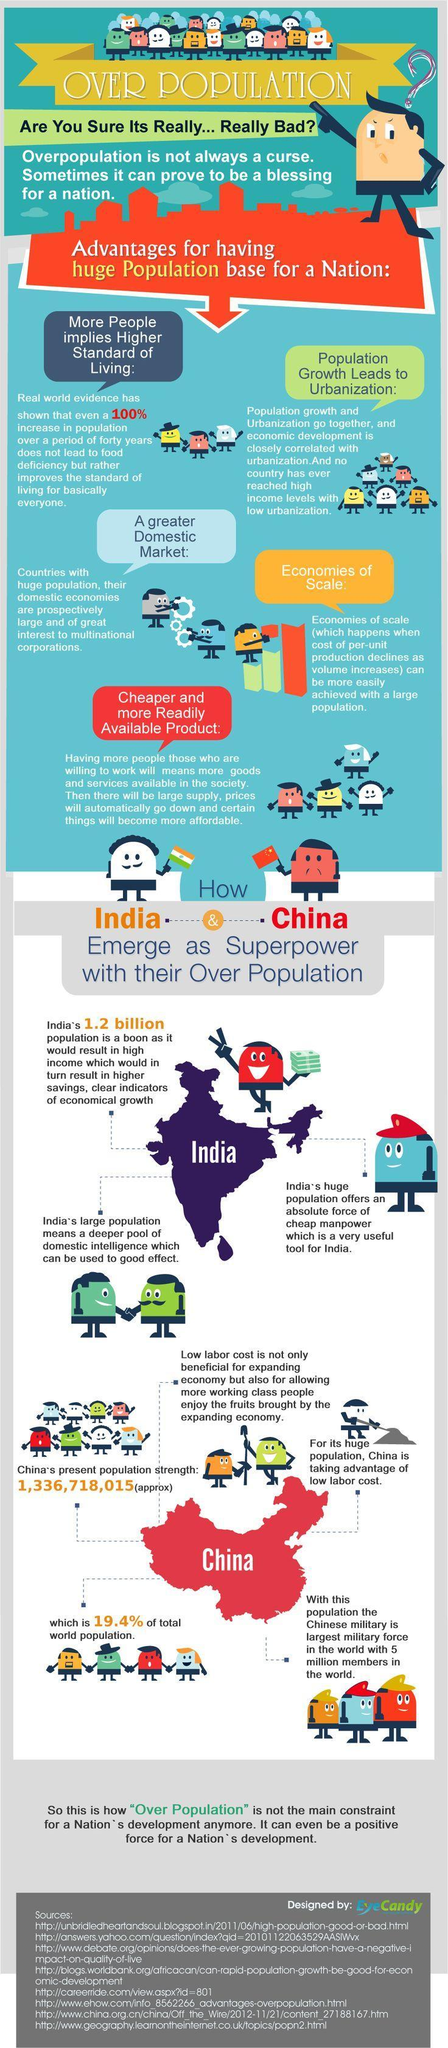How many Indian flags are in this infographic?
Answer the question with a short phrase. 1 